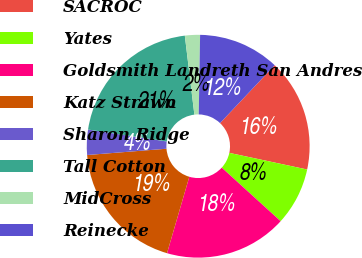Convert chart to OTSL. <chart><loc_0><loc_0><loc_500><loc_500><pie_chart><fcel>SACROC<fcel>Yates<fcel>Goldsmith Landreth San Andres<fcel>Katz Strawn<fcel>Sharon Ridge<fcel>Tall Cotton<fcel>MidCross<fcel>Reinecke<nl><fcel>16.31%<fcel>8.4%<fcel>17.77%<fcel>19.23%<fcel>3.65%<fcel>20.69%<fcel>2.19%<fcel>11.77%<nl></chart> 